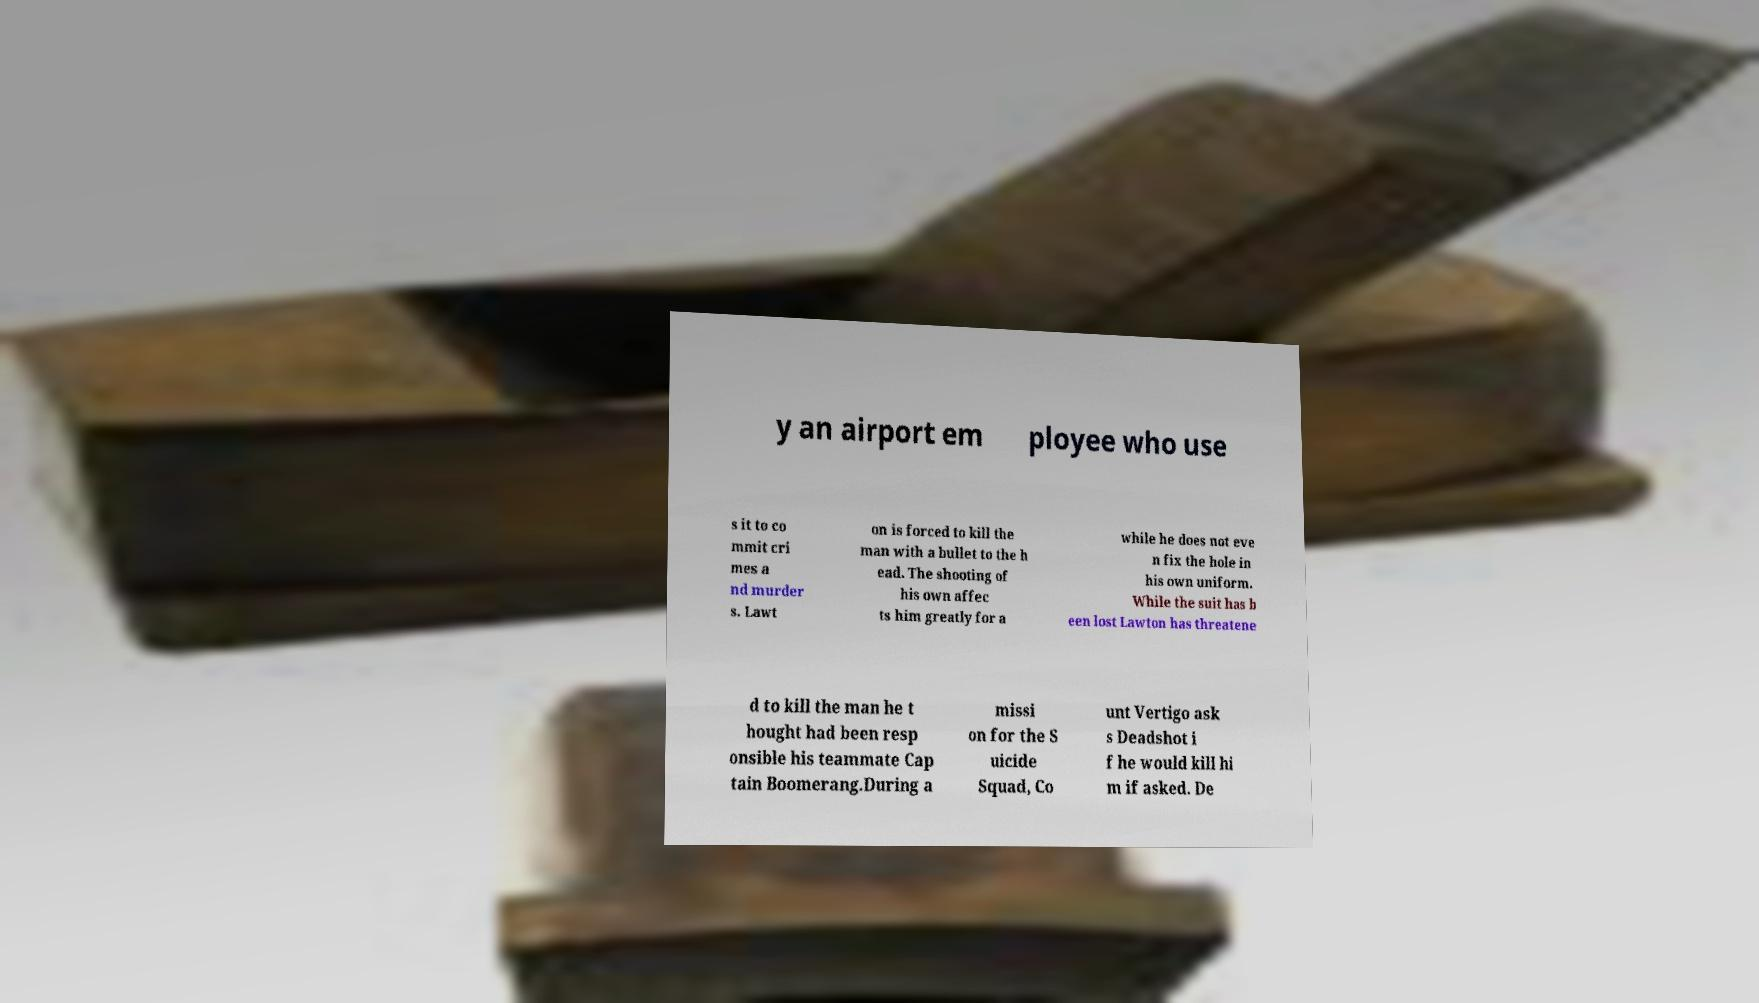Can you read and provide the text displayed in the image?This photo seems to have some interesting text. Can you extract and type it out for me? y an airport em ployee who use s it to co mmit cri mes a nd murder s. Lawt on is forced to kill the man with a bullet to the h ead. The shooting of his own affec ts him greatly for a while he does not eve n fix the hole in his own uniform. While the suit has b een lost Lawton has threatene d to kill the man he t hought had been resp onsible his teammate Cap tain Boomerang.During a missi on for the S uicide Squad, Co unt Vertigo ask s Deadshot i f he would kill hi m if asked. De 